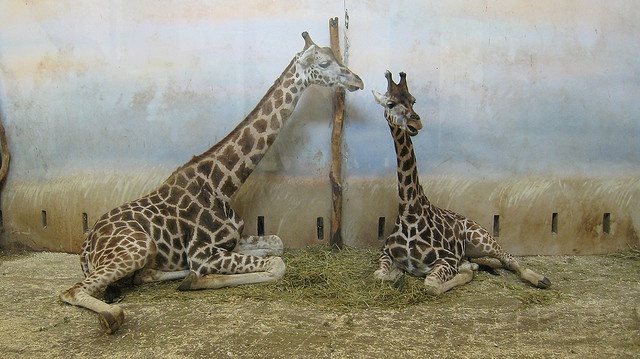Describe the objects in this image and their specific colors. I can see giraffe in lightgray, darkgray, and gray tones and giraffe in lightgray, black, gray, and darkgray tones in this image. 